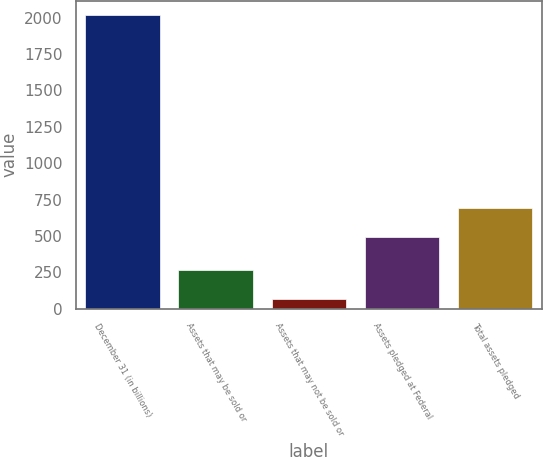Convert chart. <chart><loc_0><loc_0><loc_500><loc_500><bar_chart><fcel>December 31 (in billions)<fcel>Assets that may be sold or<fcel>Assets that may not be sold or<fcel>Assets pledged at Federal<fcel>Total assets pledged<nl><fcel>2017<fcel>262.81<fcel>67.9<fcel>493.7<fcel>691.2<nl></chart> 